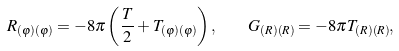Convert formula to latex. <formula><loc_0><loc_0><loc_500><loc_500>R _ { ( \varphi ) ( \varphi ) } = - 8 \pi \left ( \frac { T } { 2 } + T _ { ( \varphi ) ( \varphi ) } \right ) , \quad G _ { ( R ) ( R ) } = - 8 \pi T _ { ( R ) ( R ) } ,</formula> 